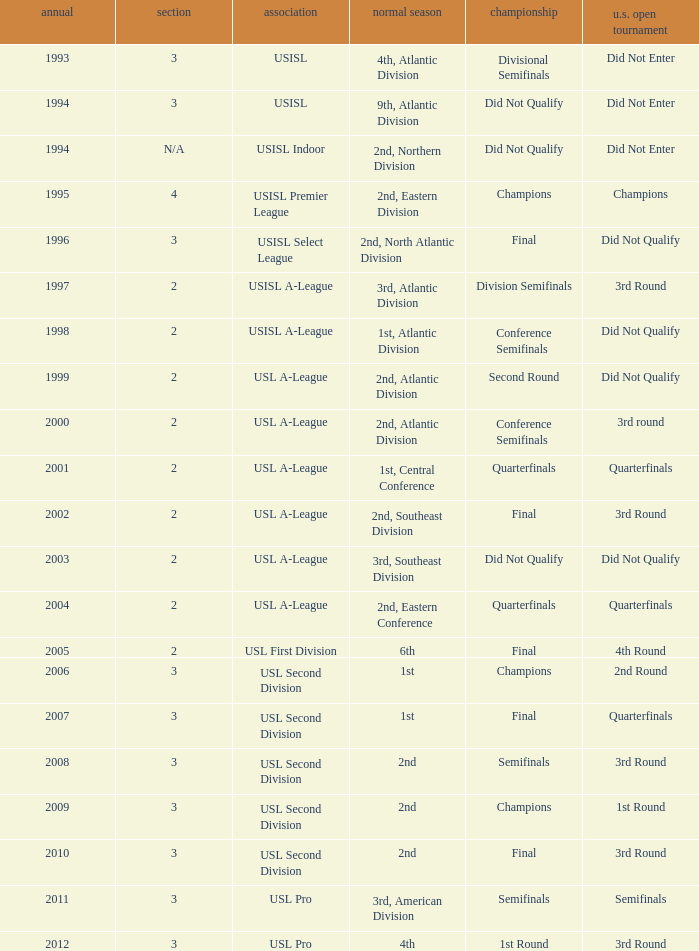Which round is u.s. open cup division semifinals 3rd Round. 